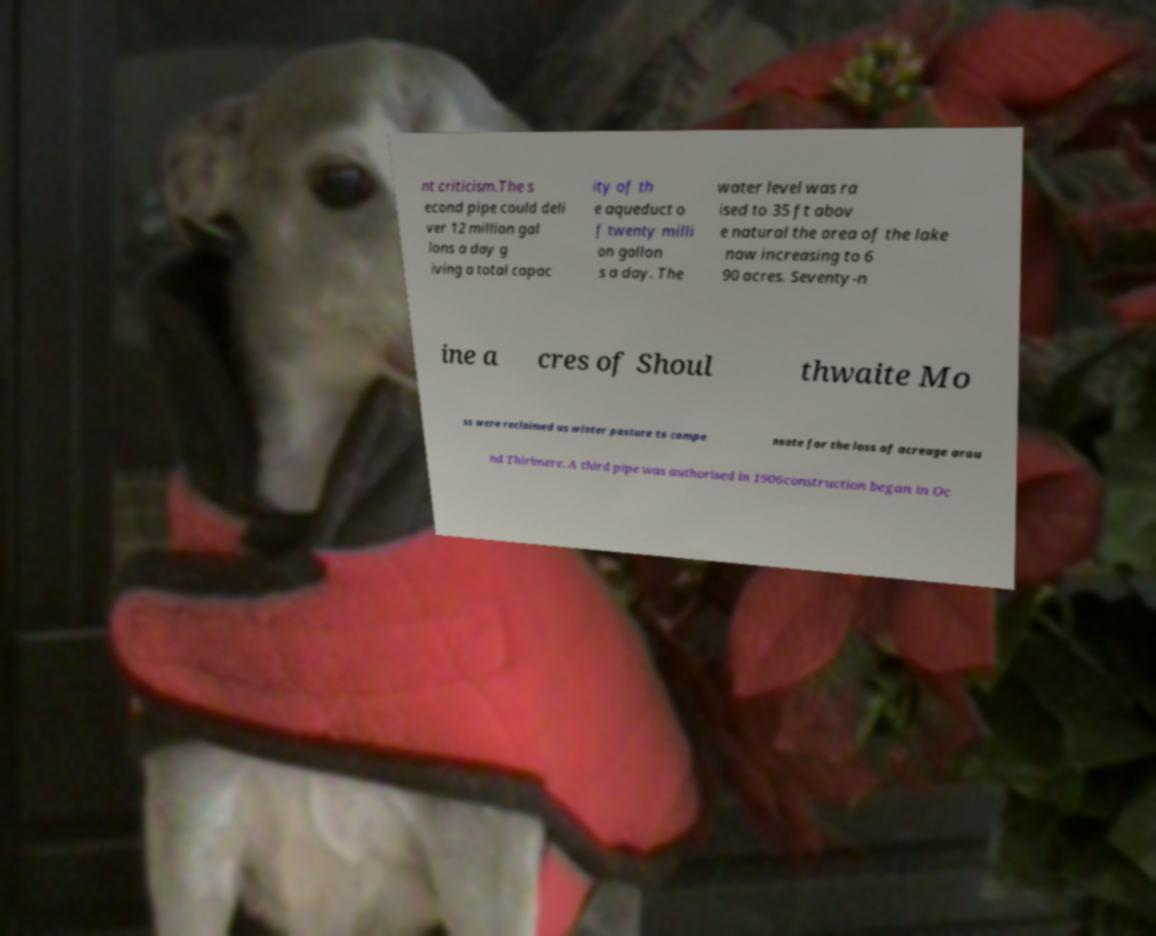For documentation purposes, I need the text within this image transcribed. Could you provide that? nt criticism.The s econd pipe could deli ver 12 million gal lons a day g iving a total capac ity of th e aqueduct o f twenty milli on gallon s a day. The water level was ra ised to 35 ft abov e natural the area of the lake now increasing to 6 90 acres. Seventy-n ine a cres of Shoul thwaite Mo ss were reclaimed as winter pasture to compe nsate for the loss of acreage arou nd Thirlmere. A third pipe was authorised in 1906construction began in Oc 